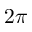<formula> <loc_0><loc_0><loc_500><loc_500>2 \pi</formula> 